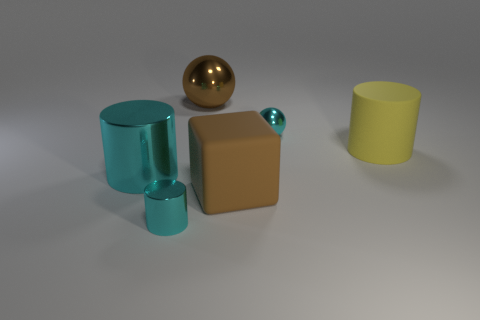Is the block the same color as the large shiny ball?
Your answer should be very brief. Yes. Is the color of the large cylinder left of the large block the same as the small shiny object that is right of the small cyan cylinder?
Provide a succinct answer. Yes. Is there any other thing of the same color as the big rubber block?
Your answer should be compact. Yes. The thing that is in front of the large cyan shiny object and left of the brown metallic sphere is what color?
Keep it short and to the point. Cyan. There is a metallic thing that is behind the cyan ball; is its size the same as the cyan sphere?
Keep it short and to the point. No. Is the number of brown objects that are in front of the yellow cylinder greater than the number of large cyan cylinders?
Make the answer very short. No. Is the shape of the large yellow rubber thing the same as the large cyan metal object?
Offer a very short reply. Yes. How big is the brown ball?
Your answer should be compact. Large. Are there more small cyan things that are behind the large yellow rubber thing than tiny objects that are left of the big cyan metallic thing?
Give a very brief answer. Yes. Are there any brown objects left of the brown rubber thing?
Provide a short and direct response. Yes. 